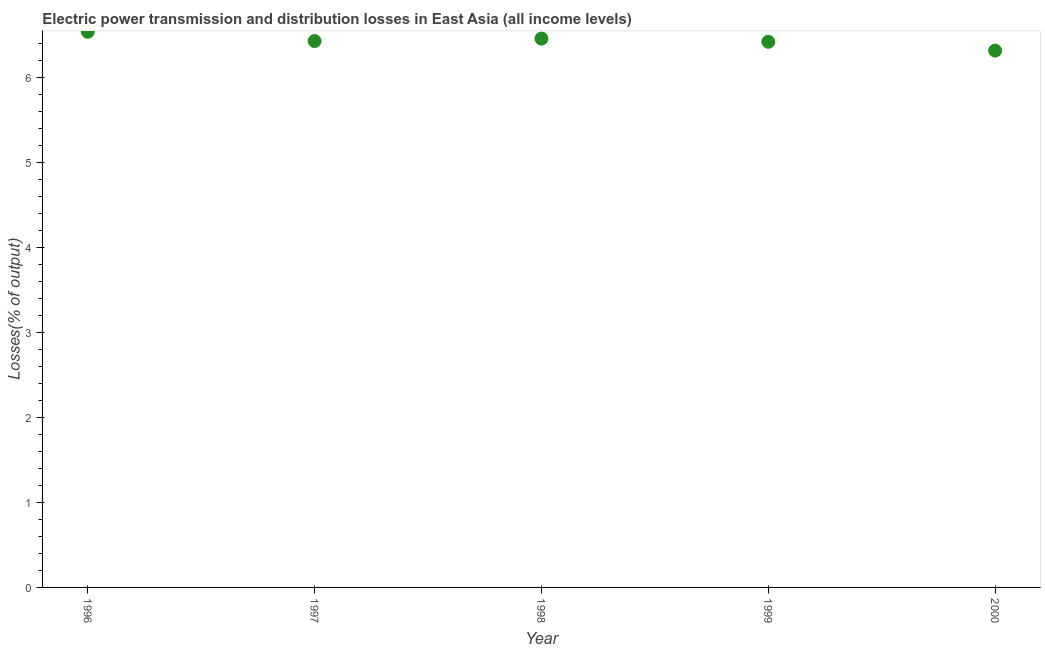What is the electric power transmission and distribution losses in 1998?
Your response must be concise. 6.46. Across all years, what is the maximum electric power transmission and distribution losses?
Offer a terse response. 6.54. Across all years, what is the minimum electric power transmission and distribution losses?
Your answer should be very brief. 6.32. In which year was the electric power transmission and distribution losses maximum?
Your response must be concise. 1996. In which year was the electric power transmission and distribution losses minimum?
Keep it short and to the point. 2000. What is the sum of the electric power transmission and distribution losses?
Your answer should be compact. 32.18. What is the difference between the electric power transmission and distribution losses in 1997 and 1998?
Ensure brevity in your answer.  -0.03. What is the average electric power transmission and distribution losses per year?
Offer a terse response. 6.44. What is the median electric power transmission and distribution losses?
Your answer should be very brief. 6.43. What is the ratio of the electric power transmission and distribution losses in 1999 to that in 2000?
Provide a succinct answer. 1.02. What is the difference between the highest and the second highest electric power transmission and distribution losses?
Make the answer very short. 0.08. What is the difference between the highest and the lowest electric power transmission and distribution losses?
Give a very brief answer. 0.22. In how many years, is the electric power transmission and distribution losses greater than the average electric power transmission and distribution losses taken over all years?
Make the answer very short. 2. Does the electric power transmission and distribution losses monotonically increase over the years?
Keep it short and to the point. No. How many dotlines are there?
Your answer should be compact. 1. Are the values on the major ticks of Y-axis written in scientific E-notation?
Your answer should be compact. No. Does the graph contain any zero values?
Make the answer very short. No. Does the graph contain grids?
Your answer should be very brief. No. What is the title of the graph?
Offer a terse response. Electric power transmission and distribution losses in East Asia (all income levels). What is the label or title of the Y-axis?
Provide a succinct answer. Losses(% of output). What is the Losses(% of output) in 1996?
Offer a very short reply. 6.54. What is the Losses(% of output) in 1997?
Give a very brief answer. 6.43. What is the Losses(% of output) in 1998?
Your response must be concise. 6.46. What is the Losses(% of output) in 1999?
Give a very brief answer. 6.42. What is the Losses(% of output) in 2000?
Give a very brief answer. 6.32. What is the difference between the Losses(% of output) in 1996 and 1997?
Provide a succinct answer. 0.11. What is the difference between the Losses(% of output) in 1996 and 1998?
Your answer should be very brief. 0.08. What is the difference between the Losses(% of output) in 1996 and 1999?
Make the answer very short. 0.12. What is the difference between the Losses(% of output) in 1996 and 2000?
Your answer should be very brief. 0.22. What is the difference between the Losses(% of output) in 1997 and 1998?
Make the answer very short. -0.03. What is the difference between the Losses(% of output) in 1997 and 1999?
Provide a succinct answer. 0.01. What is the difference between the Losses(% of output) in 1997 and 2000?
Offer a terse response. 0.11. What is the difference between the Losses(% of output) in 1998 and 1999?
Make the answer very short. 0.04. What is the difference between the Losses(% of output) in 1998 and 2000?
Your response must be concise. 0.14. What is the difference between the Losses(% of output) in 1999 and 2000?
Your response must be concise. 0.1. What is the ratio of the Losses(% of output) in 1996 to that in 1997?
Give a very brief answer. 1.02. What is the ratio of the Losses(% of output) in 1996 to that in 1999?
Provide a short and direct response. 1.02. What is the ratio of the Losses(% of output) in 1996 to that in 2000?
Keep it short and to the point. 1.03. What is the ratio of the Losses(% of output) in 1997 to that in 1999?
Offer a very short reply. 1. What is the ratio of the Losses(% of output) in 1997 to that in 2000?
Provide a succinct answer. 1.02. What is the ratio of the Losses(% of output) in 1998 to that in 1999?
Your response must be concise. 1.01. What is the ratio of the Losses(% of output) in 1998 to that in 2000?
Provide a succinct answer. 1.02. What is the ratio of the Losses(% of output) in 1999 to that in 2000?
Give a very brief answer. 1.02. 